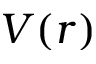Convert formula to latex. <formula><loc_0><loc_0><loc_500><loc_500>V ( r )</formula> 